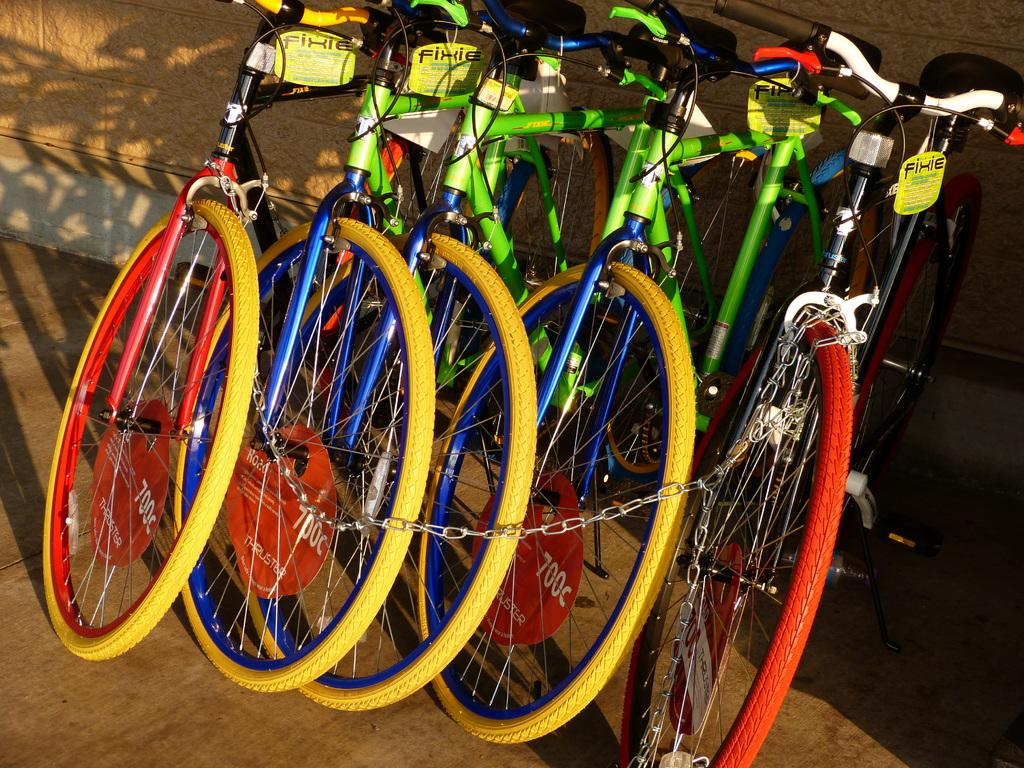What type of vehicles are in the image? There are cycles in the image. How can the cycles be distinguished from one another? The cycles are in different colors. What else is present in the image besides the cycles? There are banners and a chain in the image. What can be seen in the background of the image? There is a wall in the background of the image. What type of hen is wearing a dress and cooking in the image? There is no hen, dress, or cooking activity present in the image. 